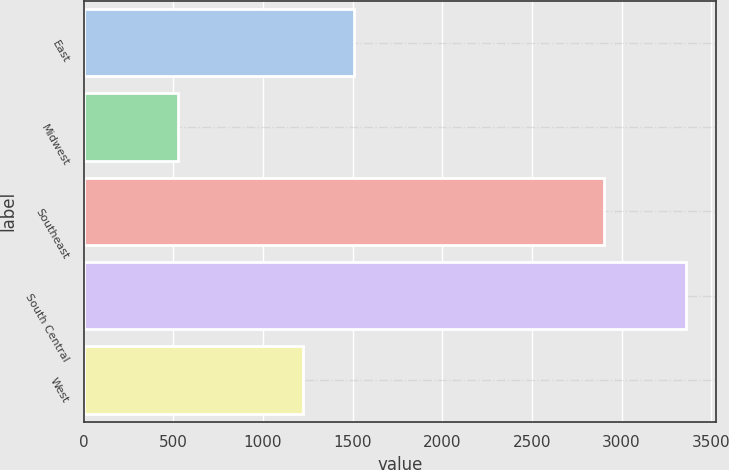<chart> <loc_0><loc_0><loc_500><loc_500><bar_chart><fcel>East<fcel>Midwest<fcel>Southeast<fcel>South Central<fcel>West<nl><fcel>1509.1<fcel>527<fcel>2901<fcel>3358<fcel>1226<nl></chart> 